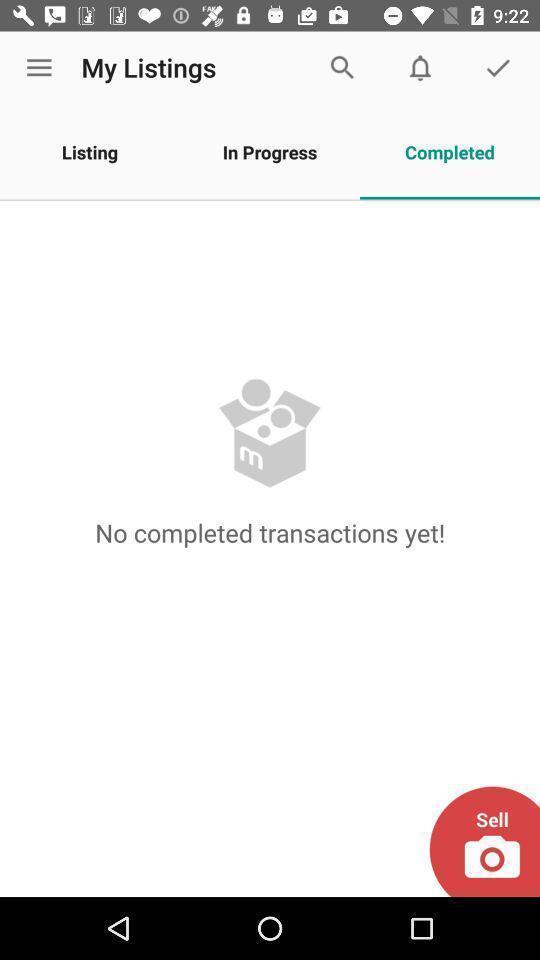Describe the content in this image. Screen shows my listings. 